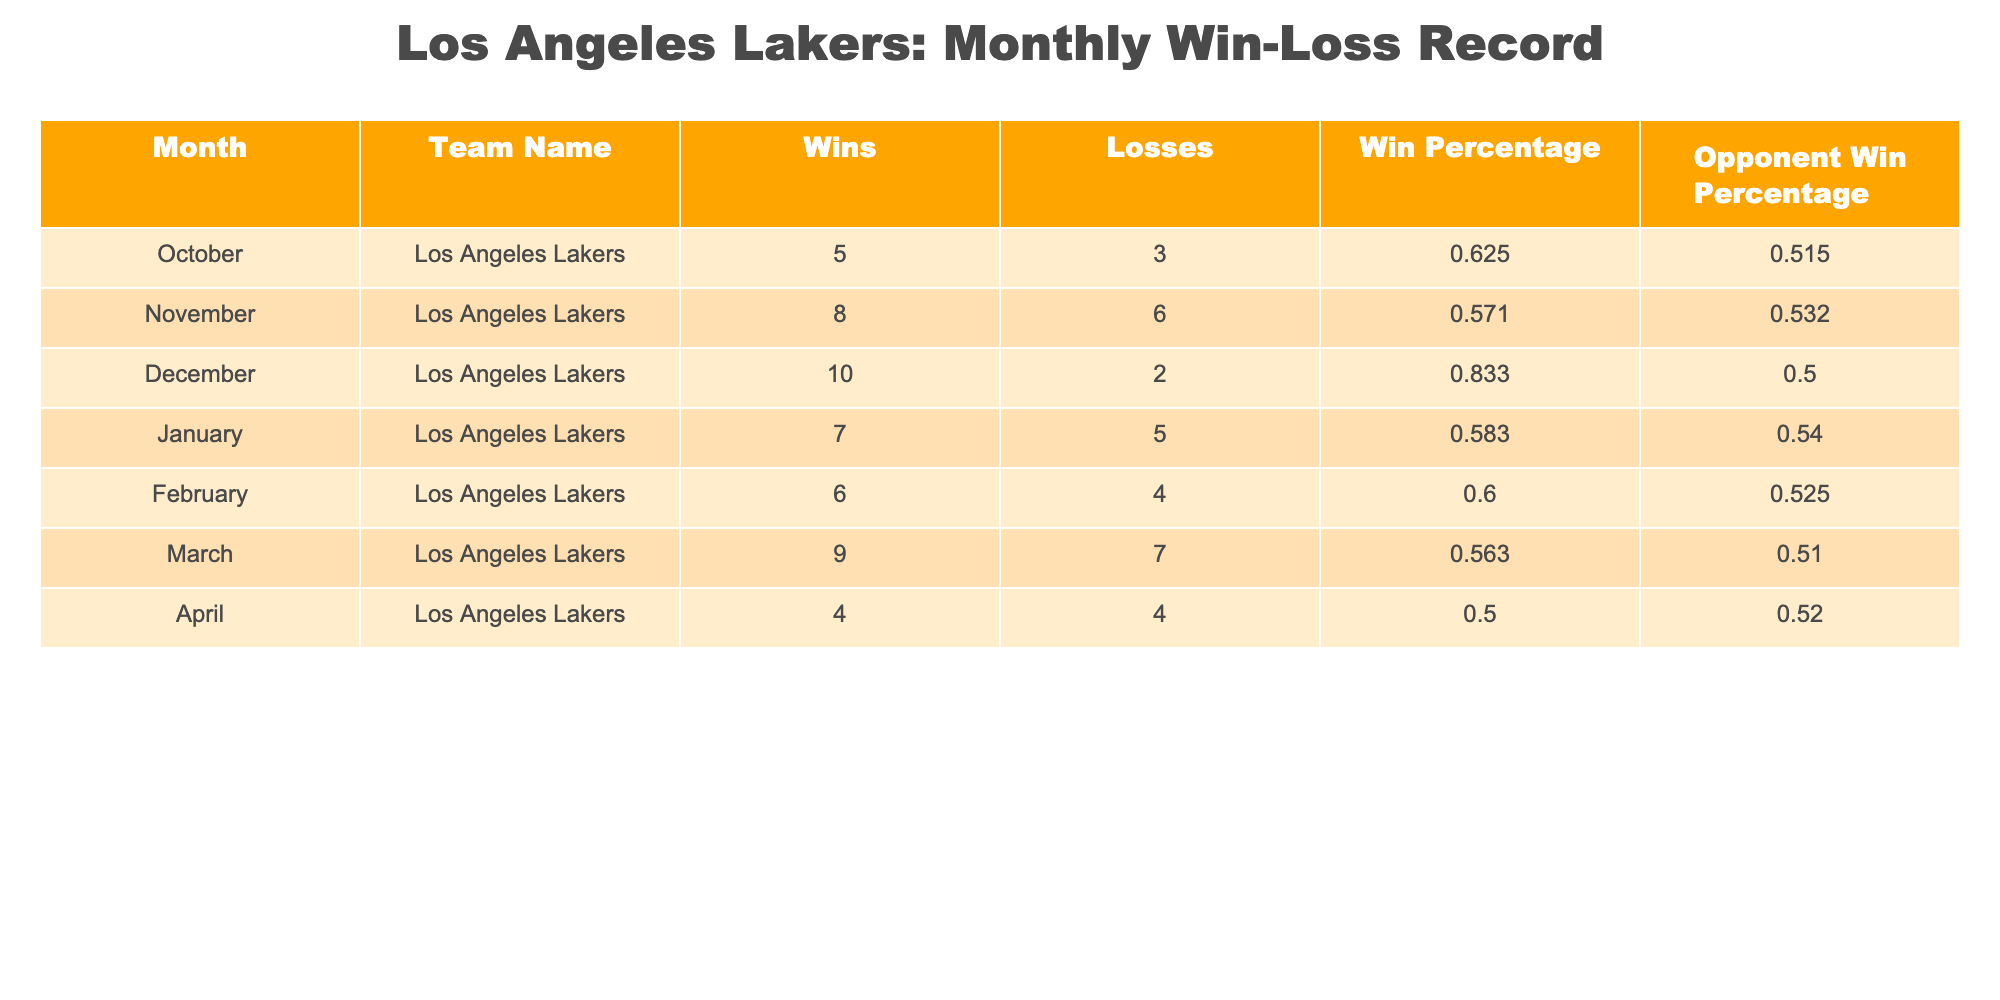What was the team's win percentage in December? In the table, for December, the column labeled "Win Percentage" indicates a value of 0.833 for the Los Angeles Lakers. This means the team's win percentage in December was specifically recorded as 0.833.
Answer: 0.833 How many wins did the team achieve in November? Looking at the table, the "Wins" column for November shows that the Los Angeles Lakers achieved a total of 8 wins during that month.
Answer: 8 What month did the team have the highest win percentage? By comparing the "Win Percentage" values for each month in the table, December shows the highest value at 0.833, indicating that the team had the most successful performance in that month.
Answer: December Did the team have more losses than wins in April? For April, the "Wins" column shows 4 wins while the "Losses" column shows 4 losses. Since the number of wins equals the number of losses, the statement is false.
Answer: No What is the average win percentage across all months? To find the average win percentage, I will add the win percentages for all months: 0.625 + 0.571 + 0.833 + 0.583 + 0.600 + 0.563 + 0.500 = 4.375. Since there are 7 months, the average win percentage is 4.375 divided by 7, which gives approximately 0.625.
Answer: 0.625 How many total wins did the team have in the first half of the season (October to December)? The number of wins in October is 5, in November is 8, and in December is 10. Adding those together: 5 + 8 + 10 = 23. Therefore, the total wins in the first half of the season is 23.
Answer: 23 Was the opponent's win percentage higher than the team's win percentage in February? In February, the "Win Percentage" of the Lakers is 0.600, while the "Opponent Win Percentage" is 0.525. Since 0.600 is greater than 0.525, the statement is false.
Answer: No What was the total number of games played by the Los Angeles Lakers in March? In March, the table indicates that the team had 9 wins and 7 losses. To find the total number of games played, I add the wins and losses: 9 + 7 = 16. Thus, the total number of games played in March is 16.
Answer: 16 Which month had the largest difference between wins and losses? By calculating the difference between wins and losses for each month, we find: October (2), November (2), December (8), January (2), February (2), March (2), and April (0). December has the largest difference, with 10 total wins and only 2 losses.
Answer: December 